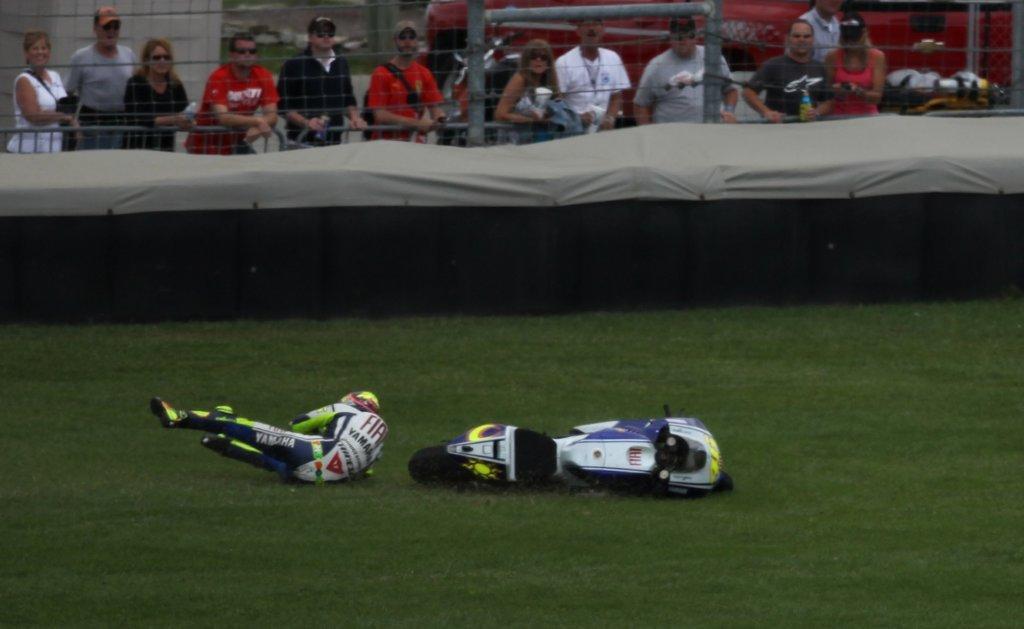How would you summarize this image in a sentence or two? Here we can see a person and a bike on the ground. This is cloth and there is a fence. Here we can see few persons. 